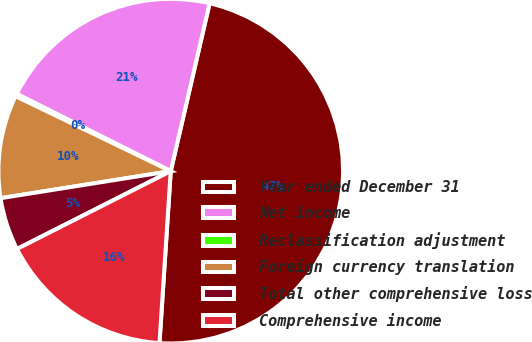Convert chart. <chart><loc_0><loc_0><loc_500><loc_500><pie_chart><fcel>Year ended December 31<fcel>Net income<fcel>Reclassification adjustment<fcel>Foreign currency translation<fcel>Total other comprehensive loss<fcel>Comprehensive income<nl><fcel>47.42%<fcel>21.22%<fcel>0.24%<fcel>9.67%<fcel>4.95%<fcel>16.5%<nl></chart> 